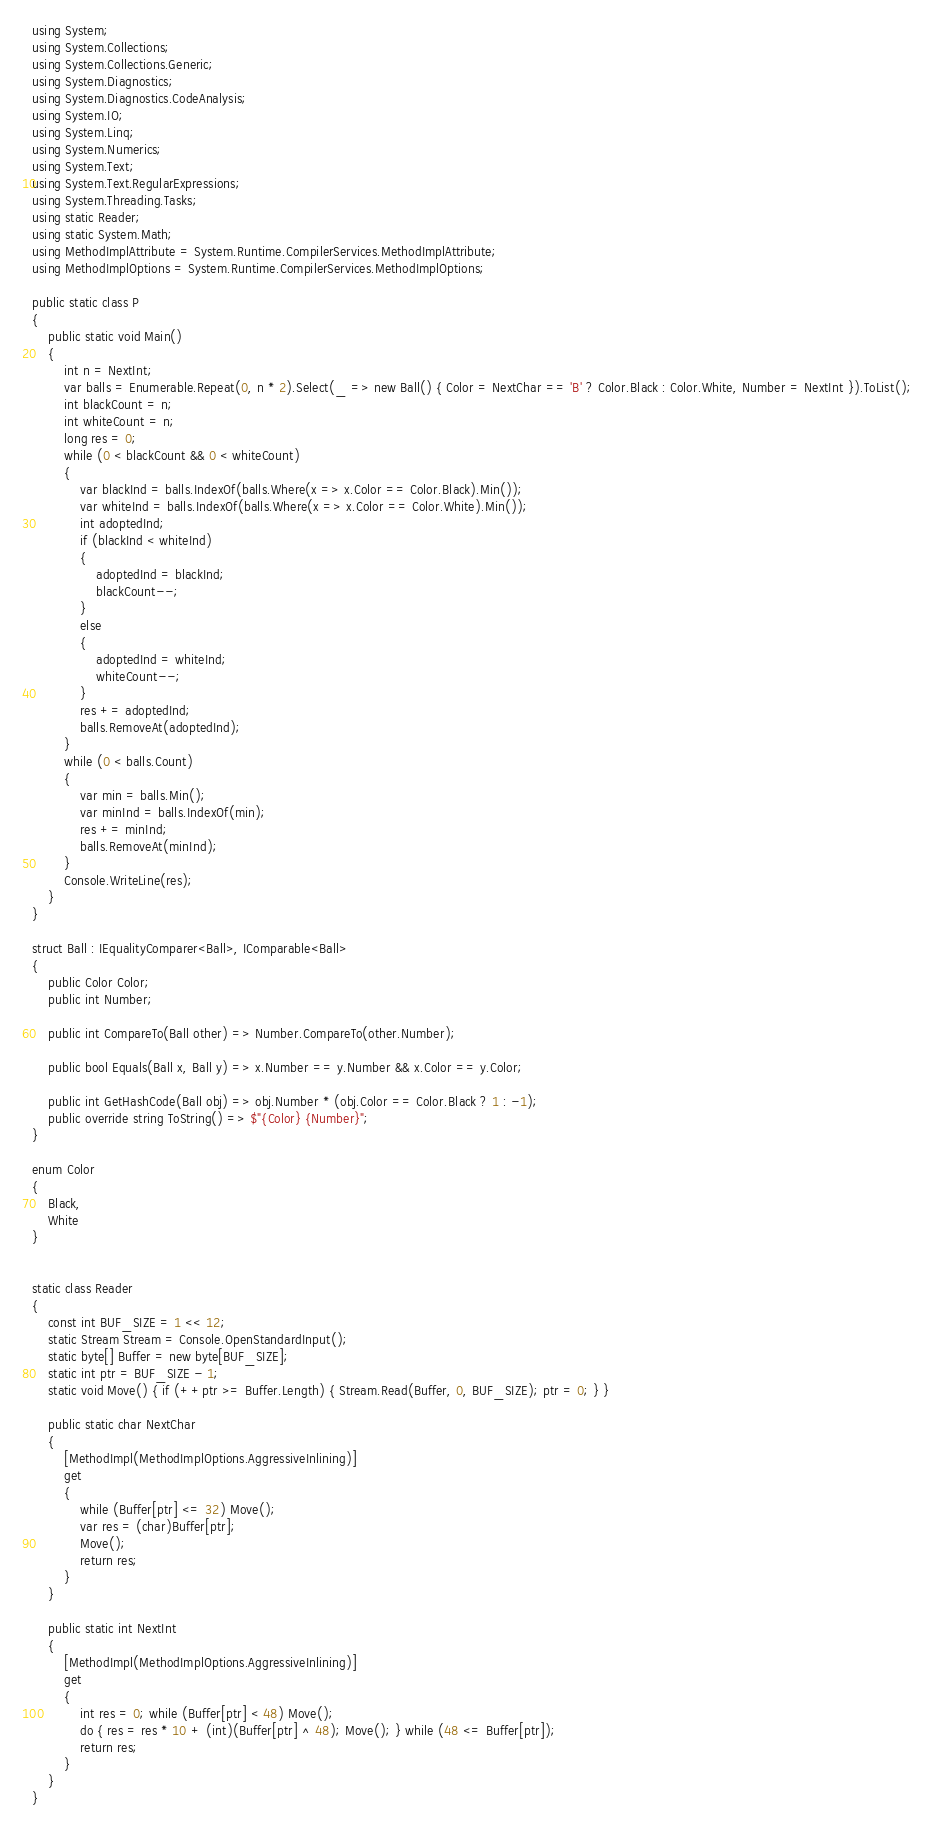<code> <loc_0><loc_0><loc_500><loc_500><_C#_>using System;
using System.Collections;
using System.Collections.Generic;
using System.Diagnostics;
using System.Diagnostics.CodeAnalysis;
using System.IO;
using System.Linq;
using System.Numerics;
using System.Text;
using System.Text.RegularExpressions;
using System.Threading.Tasks;
using static Reader;
using static System.Math;
using MethodImplAttribute = System.Runtime.CompilerServices.MethodImplAttribute;
using MethodImplOptions = System.Runtime.CompilerServices.MethodImplOptions;

public static class P
{
    public static void Main()
    {
        int n = NextInt;
        var balls = Enumerable.Repeat(0, n * 2).Select(_ => new Ball() { Color = NextChar == 'B' ? Color.Black : Color.White, Number = NextInt }).ToList();
        int blackCount = n;
        int whiteCount = n;
        long res = 0;
        while (0 < blackCount && 0 < whiteCount)
        {
            var blackInd = balls.IndexOf(balls.Where(x => x.Color == Color.Black).Min());
            var whiteInd = balls.IndexOf(balls.Where(x => x.Color == Color.White).Min());
            int adoptedInd;
            if (blackInd < whiteInd)
            {
                adoptedInd = blackInd;
                blackCount--;
            }
            else
            {
                adoptedInd = whiteInd;
                whiteCount--;
            }
            res += adoptedInd;
            balls.RemoveAt(adoptedInd);
        }
        while (0 < balls.Count)
        {
            var min = balls.Min();
            var minInd = balls.IndexOf(min);
            res += minInd;
            balls.RemoveAt(minInd);
        }
        Console.WriteLine(res);
    }
}

struct Ball : IEqualityComparer<Ball>, IComparable<Ball>
{
    public Color Color;
    public int Number;

    public int CompareTo(Ball other) => Number.CompareTo(other.Number);

    public bool Equals(Ball x, Ball y) => x.Number == y.Number && x.Color == y.Color;

    public int GetHashCode(Ball obj) => obj.Number * (obj.Color == Color.Black ? 1 : -1);
    public override string ToString() => $"{Color} {Number}";
}

enum Color
{
    Black,
    White
}


static class Reader
{
    const int BUF_SIZE = 1 << 12;
    static Stream Stream = Console.OpenStandardInput();
    static byte[] Buffer = new byte[BUF_SIZE];
    static int ptr = BUF_SIZE - 1;
    static void Move() { if (++ptr >= Buffer.Length) { Stream.Read(Buffer, 0, BUF_SIZE); ptr = 0; } }

    public static char NextChar
    {
        [MethodImpl(MethodImplOptions.AggressiveInlining)]
        get
        {
            while (Buffer[ptr] <= 32) Move();
            var res = (char)Buffer[ptr];
            Move();
            return res;
        }
    }

    public static int NextInt
    {
        [MethodImpl(MethodImplOptions.AggressiveInlining)]
        get
        {
            int res = 0; while (Buffer[ptr] < 48) Move();
            do { res = res * 10 + (int)(Buffer[ptr] ^ 48); Move(); } while (48 <= Buffer[ptr]);
            return res;
        }
    }
}
</code> 